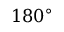Convert formula to latex. <formula><loc_0><loc_0><loc_500><loc_500>1 8 0 ^ { \circ }</formula> 